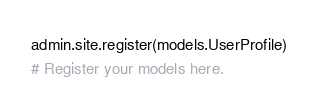<code> <loc_0><loc_0><loc_500><loc_500><_Python_>admin.site.register(models.UserProfile)
# Register your models here.
</code> 